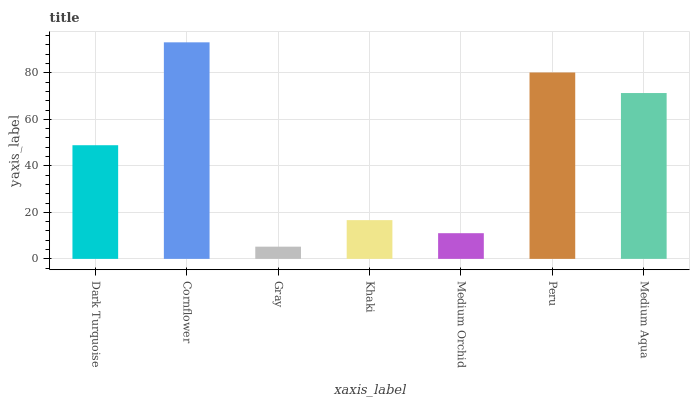Is Gray the minimum?
Answer yes or no. Yes. Is Cornflower the maximum?
Answer yes or no. Yes. Is Cornflower the minimum?
Answer yes or no. No. Is Gray the maximum?
Answer yes or no. No. Is Cornflower greater than Gray?
Answer yes or no. Yes. Is Gray less than Cornflower?
Answer yes or no. Yes. Is Gray greater than Cornflower?
Answer yes or no. No. Is Cornflower less than Gray?
Answer yes or no. No. Is Dark Turquoise the high median?
Answer yes or no. Yes. Is Dark Turquoise the low median?
Answer yes or no. Yes. Is Medium Orchid the high median?
Answer yes or no. No. Is Gray the low median?
Answer yes or no. No. 